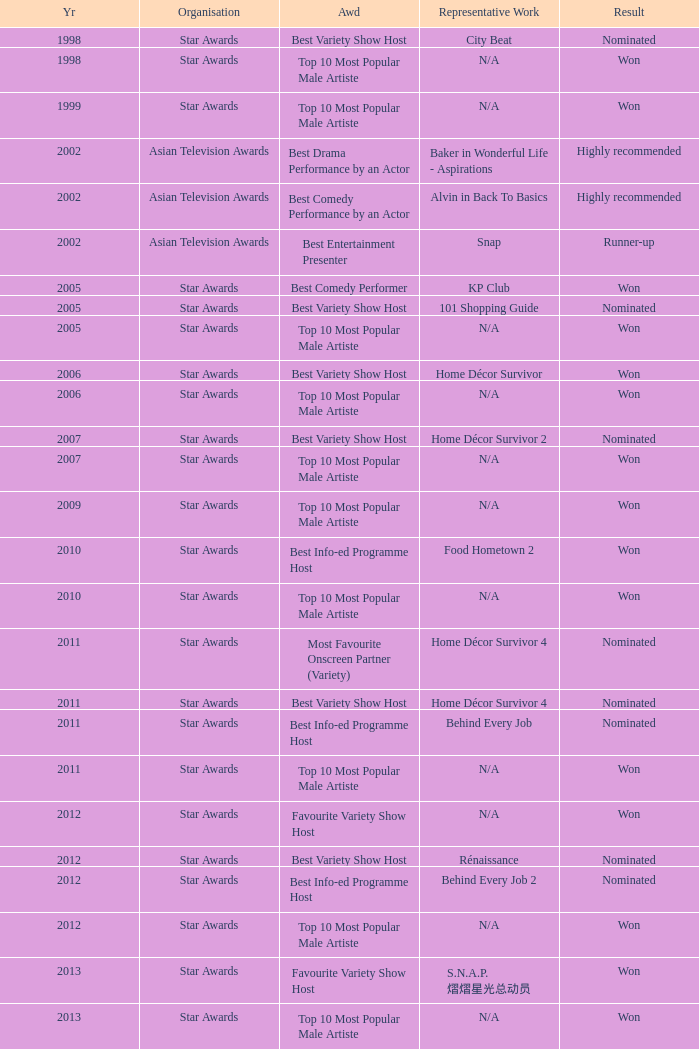What is the award for 1998 with Representative Work of city beat? Best Variety Show Host. Can you give me this table as a dict? {'header': ['Yr', 'Organisation', 'Awd', 'Representative Work', 'Result'], 'rows': [['1998', 'Star Awards', 'Best Variety Show Host', 'City Beat', 'Nominated'], ['1998', 'Star Awards', 'Top 10 Most Popular Male Artiste', 'N/A', 'Won'], ['1999', 'Star Awards', 'Top 10 Most Popular Male Artiste', 'N/A', 'Won'], ['2002', 'Asian Television Awards', 'Best Drama Performance by an Actor', 'Baker in Wonderful Life - Aspirations', 'Highly recommended'], ['2002', 'Asian Television Awards', 'Best Comedy Performance by an Actor', 'Alvin in Back To Basics', 'Highly recommended'], ['2002', 'Asian Television Awards', 'Best Entertainment Presenter', 'Snap', 'Runner-up'], ['2005', 'Star Awards', 'Best Comedy Performer', 'KP Club', 'Won'], ['2005', 'Star Awards', 'Best Variety Show Host', '101 Shopping Guide', 'Nominated'], ['2005', 'Star Awards', 'Top 10 Most Popular Male Artiste', 'N/A', 'Won'], ['2006', 'Star Awards', 'Best Variety Show Host', 'Home Décor Survivor', 'Won'], ['2006', 'Star Awards', 'Top 10 Most Popular Male Artiste', 'N/A', 'Won'], ['2007', 'Star Awards', 'Best Variety Show Host', 'Home Décor Survivor 2', 'Nominated'], ['2007', 'Star Awards', 'Top 10 Most Popular Male Artiste', 'N/A', 'Won'], ['2009', 'Star Awards', 'Top 10 Most Popular Male Artiste', 'N/A', 'Won'], ['2010', 'Star Awards', 'Best Info-ed Programme Host', 'Food Hometown 2', 'Won'], ['2010', 'Star Awards', 'Top 10 Most Popular Male Artiste', 'N/A', 'Won'], ['2011', 'Star Awards', 'Most Favourite Onscreen Partner (Variety)', 'Home Décor Survivor 4', 'Nominated'], ['2011', 'Star Awards', 'Best Variety Show Host', 'Home Décor Survivor 4', 'Nominated'], ['2011', 'Star Awards', 'Best Info-ed Programme Host', 'Behind Every Job', 'Nominated'], ['2011', 'Star Awards', 'Top 10 Most Popular Male Artiste', 'N/A', 'Won'], ['2012', 'Star Awards', 'Favourite Variety Show Host', 'N/A', 'Won'], ['2012', 'Star Awards', 'Best Variety Show Host', 'Rénaissance', 'Nominated'], ['2012', 'Star Awards', 'Best Info-ed Programme Host', 'Behind Every Job 2', 'Nominated'], ['2012', 'Star Awards', 'Top 10 Most Popular Male Artiste', 'N/A', 'Won'], ['2013', 'Star Awards', 'Favourite Variety Show Host', 'S.N.A.P. 熠熠星光总动员', 'Won'], ['2013', 'Star Awards', 'Top 10 Most Popular Male Artiste', 'N/A', 'Won'], ['2013', 'Star Awards', 'Best Info-Ed Programme Host', 'Makan Unlimited', 'Nominated'], ['2013', 'Star Awards', 'Best Variety Show Host', 'Jobs Around The World', 'Nominated']]} 